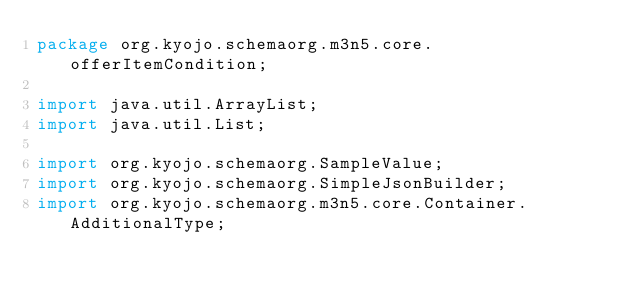<code> <loc_0><loc_0><loc_500><loc_500><_Java_>package org.kyojo.schemaorg.m3n5.core.offerItemCondition;

import java.util.ArrayList;
import java.util.List;

import org.kyojo.schemaorg.SampleValue;
import org.kyojo.schemaorg.SimpleJsonBuilder;
import org.kyojo.schemaorg.m3n5.core.Container.AdditionalType;</code> 